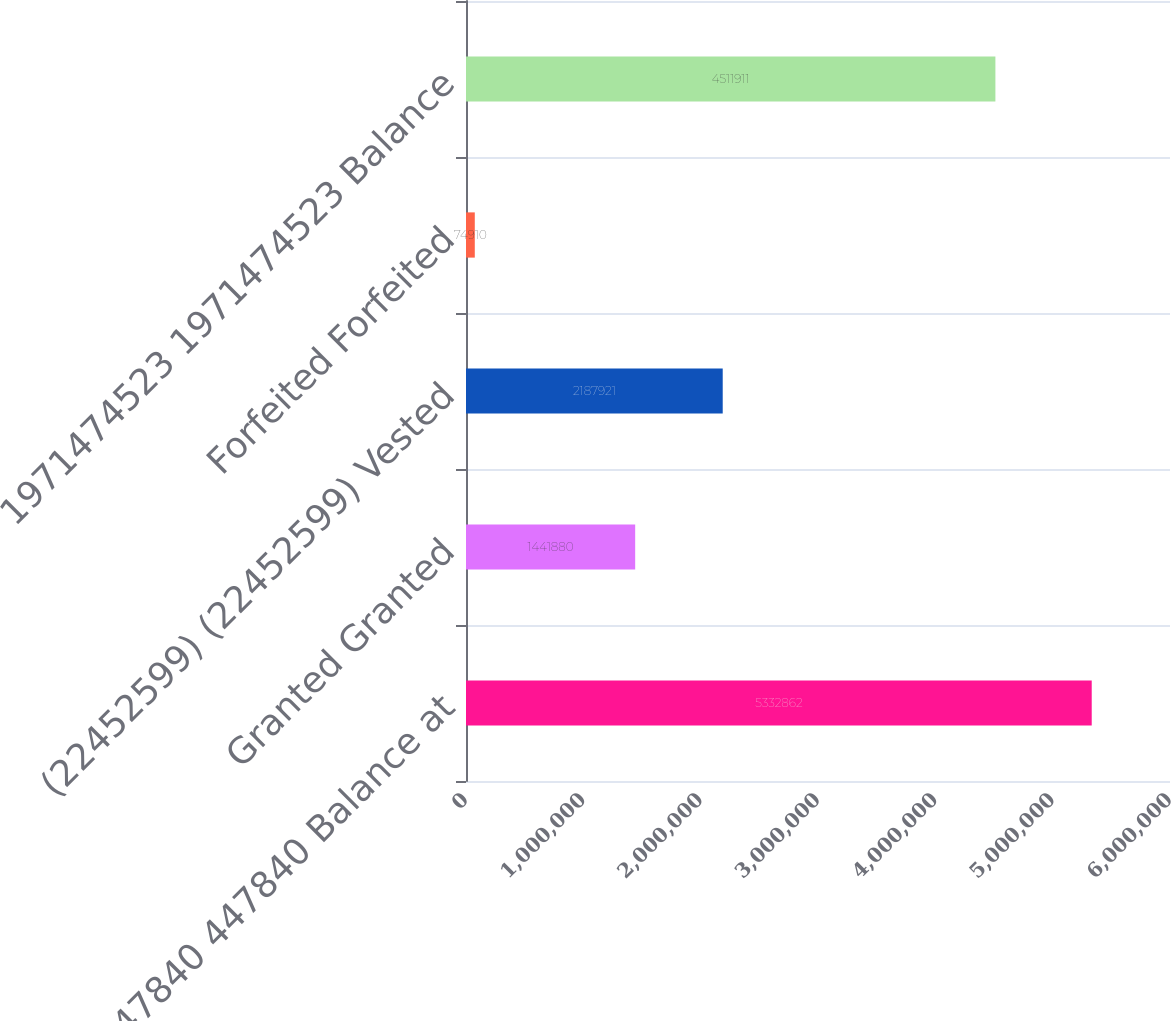<chart> <loc_0><loc_0><loc_500><loc_500><bar_chart><fcel>447840 447840 Balance at<fcel>Granted Granted<fcel>(22452599) (22452599) Vested<fcel>Forfeited Forfeited<fcel>1971474523 1971474523 Balance<nl><fcel>5.33286e+06<fcel>1.44188e+06<fcel>2.18792e+06<fcel>74910<fcel>4.51191e+06<nl></chart> 